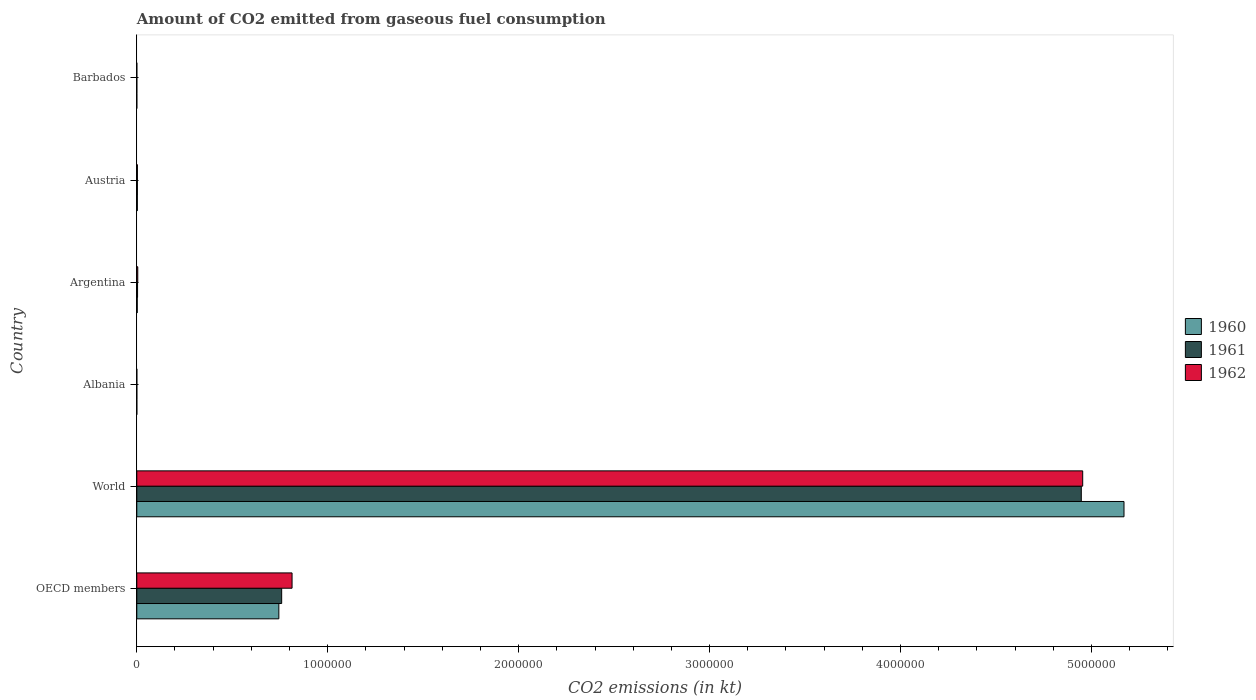How many groups of bars are there?
Your answer should be very brief. 6. Are the number of bars per tick equal to the number of legend labels?
Make the answer very short. Yes. Are the number of bars on each tick of the Y-axis equal?
Provide a short and direct response. Yes. How many bars are there on the 4th tick from the top?
Make the answer very short. 3. How many bars are there on the 3rd tick from the bottom?
Your answer should be compact. 3. What is the label of the 4th group of bars from the top?
Offer a very short reply. Albania. In how many cases, is the number of bars for a given country not equal to the number of legend labels?
Provide a succinct answer. 0. What is the amount of CO2 emitted in 1961 in Austria?
Keep it short and to the point. 3091.28. Across all countries, what is the maximum amount of CO2 emitted in 1961?
Ensure brevity in your answer.  4.95e+06. Across all countries, what is the minimum amount of CO2 emitted in 1961?
Offer a terse response. 7.33. In which country was the amount of CO2 emitted in 1960 minimum?
Keep it short and to the point. Barbados. What is the total amount of CO2 emitted in 1960 in the graph?
Your answer should be compact. 5.92e+06. What is the difference between the amount of CO2 emitted in 1960 in Argentina and that in OECD members?
Your answer should be compact. -7.42e+05. What is the difference between the amount of CO2 emitted in 1962 in Argentina and the amount of CO2 emitted in 1961 in OECD members?
Ensure brevity in your answer.  -7.54e+05. What is the average amount of CO2 emitted in 1960 per country?
Your answer should be very brief. 9.87e+05. What is the difference between the amount of CO2 emitted in 1961 and amount of CO2 emitted in 1962 in Argentina?
Your answer should be very brief. -1078.1. What is the ratio of the amount of CO2 emitted in 1960 in Albania to that in Austria?
Your response must be concise. 0.03. What is the difference between the highest and the second highest amount of CO2 emitted in 1962?
Your answer should be compact. 4.14e+06. What is the difference between the highest and the lowest amount of CO2 emitted in 1960?
Offer a very short reply. 5.17e+06. In how many countries, is the amount of CO2 emitted in 1960 greater than the average amount of CO2 emitted in 1960 taken over all countries?
Give a very brief answer. 1. Is the sum of the amount of CO2 emitted in 1960 in Austria and World greater than the maximum amount of CO2 emitted in 1961 across all countries?
Your response must be concise. Yes. What does the 1st bar from the top in Barbados represents?
Offer a very short reply. 1962. How many bars are there?
Make the answer very short. 18. How many countries are there in the graph?
Offer a very short reply. 6. Are the values on the major ticks of X-axis written in scientific E-notation?
Provide a succinct answer. No. Does the graph contain grids?
Offer a very short reply. No. How many legend labels are there?
Provide a succinct answer. 3. How are the legend labels stacked?
Your response must be concise. Vertical. What is the title of the graph?
Ensure brevity in your answer.  Amount of CO2 emitted from gaseous fuel consumption. Does "1982" appear as one of the legend labels in the graph?
Your answer should be compact. No. What is the label or title of the X-axis?
Your answer should be compact. CO2 emissions (in kt). What is the CO2 emissions (in kt) in 1960 in OECD members?
Your answer should be compact. 7.44e+05. What is the CO2 emissions (in kt) in 1961 in OECD members?
Offer a terse response. 7.59e+05. What is the CO2 emissions (in kt) in 1962 in OECD members?
Your answer should be compact. 8.13e+05. What is the CO2 emissions (in kt) of 1960 in World?
Keep it short and to the point. 5.17e+06. What is the CO2 emissions (in kt) of 1961 in World?
Provide a succinct answer. 4.95e+06. What is the CO2 emissions (in kt) in 1962 in World?
Make the answer very short. 4.95e+06. What is the CO2 emissions (in kt) in 1960 in Albania?
Provide a short and direct response. 84.34. What is the CO2 emissions (in kt) in 1961 in Albania?
Your response must be concise. 84.34. What is the CO2 emissions (in kt) in 1962 in Albania?
Keep it short and to the point. 84.34. What is the CO2 emissions (in kt) in 1960 in Argentina?
Offer a terse response. 2365.22. What is the CO2 emissions (in kt) in 1961 in Argentina?
Offer a very short reply. 4033.7. What is the CO2 emissions (in kt) in 1962 in Argentina?
Provide a short and direct response. 5111.8. What is the CO2 emissions (in kt) of 1960 in Austria?
Give a very brief answer. 2922.6. What is the CO2 emissions (in kt) of 1961 in Austria?
Give a very brief answer. 3091.28. What is the CO2 emissions (in kt) of 1962 in Austria?
Ensure brevity in your answer.  3241.63. What is the CO2 emissions (in kt) of 1960 in Barbados?
Your answer should be compact. 3.67. What is the CO2 emissions (in kt) of 1961 in Barbados?
Your answer should be compact. 7.33. What is the CO2 emissions (in kt) in 1962 in Barbados?
Give a very brief answer. 7.33. Across all countries, what is the maximum CO2 emissions (in kt) in 1960?
Provide a short and direct response. 5.17e+06. Across all countries, what is the maximum CO2 emissions (in kt) of 1961?
Your answer should be very brief. 4.95e+06. Across all countries, what is the maximum CO2 emissions (in kt) in 1962?
Your response must be concise. 4.95e+06. Across all countries, what is the minimum CO2 emissions (in kt) in 1960?
Give a very brief answer. 3.67. Across all countries, what is the minimum CO2 emissions (in kt) in 1961?
Your answer should be very brief. 7.33. Across all countries, what is the minimum CO2 emissions (in kt) in 1962?
Offer a very short reply. 7.33. What is the total CO2 emissions (in kt) in 1960 in the graph?
Provide a succinct answer. 5.92e+06. What is the total CO2 emissions (in kt) in 1961 in the graph?
Keep it short and to the point. 5.71e+06. What is the total CO2 emissions (in kt) in 1962 in the graph?
Your answer should be compact. 5.78e+06. What is the difference between the CO2 emissions (in kt) in 1960 in OECD members and that in World?
Give a very brief answer. -4.43e+06. What is the difference between the CO2 emissions (in kt) of 1961 in OECD members and that in World?
Make the answer very short. -4.19e+06. What is the difference between the CO2 emissions (in kt) of 1962 in OECD members and that in World?
Offer a very short reply. -4.14e+06. What is the difference between the CO2 emissions (in kt) of 1960 in OECD members and that in Albania?
Offer a very short reply. 7.44e+05. What is the difference between the CO2 emissions (in kt) of 1961 in OECD members and that in Albania?
Provide a succinct answer. 7.59e+05. What is the difference between the CO2 emissions (in kt) in 1962 in OECD members and that in Albania?
Offer a very short reply. 8.13e+05. What is the difference between the CO2 emissions (in kt) in 1960 in OECD members and that in Argentina?
Provide a succinct answer. 7.42e+05. What is the difference between the CO2 emissions (in kt) of 1961 in OECD members and that in Argentina?
Your answer should be compact. 7.55e+05. What is the difference between the CO2 emissions (in kt) in 1962 in OECD members and that in Argentina?
Provide a short and direct response. 8.08e+05. What is the difference between the CO2 emissions (in kt) of 1960 in OECD members and that in Austria?
Ensure brevity in your answer.  7.41e+05. What is the difference between the CO2 emissions (in kt) of 1961 in OECD members and that in Austria?
Offer a very short reply. 7.56e+05. What is the difference between the CO2 emissions (in kt) of 1962 in OECD members and that in Austria?
Make the answer very short. 8.10e+05. What is the difference between the CO2 emissions (in kt) in 1960 in OECD members and that in Barbados?
Provide a short and direct response. 7.44e+05. What is the difference between the CO2 emissions (in kt) of 1961 in OECD members and that in Barbados?
Provide a succinct answer. 7.59e+05. What is the difference between the CO2 emissions (in kt) in 1962 in OECD members and that in Barbados?
Offer a terse response. 8.13e+05. What is the difference between the CO2 emissions (in kt) in 1960 in World and that in Albania?
Ensure brevity in your answer.  5.17e+06. What is the difference between the CO2 emissions (in kt) in 1961 in World and that in Albania?
Your answer should be compact. 4.95e+06. What is the difference between the CO2 emissions (in kt) in 1962 in World and that in Albania?
Provide a short and direct response. 4.95e+06. What is the difference between the CO2 emissions (in kt) of 1960 in World and that in Argentina?
Your answer should be compact. 5.17e+06. What is the difference between the CO2 emissions (in kt) in 1961 in World and that in Argentina?
Provide a succinct answer. 4.94e+06. What is the difference between the CO2 emissions (in kt) of 1962 in World and that in Argentina?
Provide a succinct answer. 4.95e+06. What is the difference between the CO2 emissions (in kt) of 1960 in World and that in Austria?
Offer a very short reply. 5.17e+06. What is the difference between the CO2 emissions (in kt) of 1961 in World and that in Austria?
Make the answer very short. 4.94e+06. What is the difference between the CO2 emissions (in kt) in 1962 in World and that in Austria?
Ensure brevity in your answer.  4.95e+06. What is the difference between the CO2 emissions (in kt) in 1960 in World and that in Barbados?
Provide a succinct answer. 5.17e+06. What is the difference between the CO2 emissions (in kt) in 1961 in World and that in Barbados?
Provide a succinct answer. 4.95e+06. What is the difference between the CO2 emissions (in kt) of 1962 in World and that in Barbados?
Make the answer very short. 4.95e+06. What is the difference between the CO2 emissions (in kt) in 1960 in Albania and that in Argentina?
Provide a succinct answer. -2280.87. What is the difference between the CO2 emissions (in kt) in 1961 in Albania and that in Argentina?
Your answer should be very brief. -3949.36. What is the difference between the CO2 emissions (in kt) of 1962 in Albania and that in Argentina?
Provide a succinct answer. -5027.46. What is the difference between the CO2 emissions (in kt) in 1960 in Albania and that in Austria?
Your response must be concise. -2838.26. What is the difference between the CO2 emissions (in kt) in 1961 in Albania and that in Austria?
Keep it short and to the point. -3006.94. What is the difference between the CO2 emissions (in kt) of 1962 in Albania and that in Austria?
Offer a terse response. -3157.29. What is the difference between the CO2 emissions (in kt) of 1960 in Albania and that in Barbados?
Your answer should be compact. 80.67. What is the difference between the CO2 emissions (in kt) of 1961 in Albania and that in Barbados?
Your answer should be very brief. 77.01. What is the difference between the CO2 emissions (in kt) in 1962 in Albania and that in Barbados?
Offer a terse response. 77.01. What is the difference between the CO2 emissions (in kt) in 1960 in Argentina and that in Austria?
Ensure brevity in your answer.  -557.38. What is the difference between the CO2 emissions (in kt) of 1961 in Argentina and that in Austria?
Your response must be concise. 942.42. What is the difference between the CO2 emissions (in kt) of 1962 in Argentina and that in Austria?
Give a very brief answer. 1870.17. What is the difference between the CO2 emissions (in kt) of 1960 in Argentina and that in Barbados?
Your answer should be very brief. 2361.55. What is the difference between the CO2 emissions (in kt) of 1961 in Argentina and that in Barbados?
Provide a succinct answer. 4026.37. What is the difference between the CO2 emissions (in kt) of 1962 in Argentina and that in Barbados?
Your response must be concise. 5104.46. What is the difference between the CO2 emissions (in kt) in 1960 in Austria and that in Barbados?
Provide a succinct answer. 2918.93. What is the difference between the CO2 emissions (in kt) in 1961 in Austria and that in Barbados?
Your answer should be very brief. 3083.95. What is the difference between the CO2 emissions (in kt) of 1962 in Austria and that in Barbados?
Make the answer very short. 3234.29. What is the difference between the CO2 emissions (in kt) of 1960 in OECD members and the CO2 emissions (in kt) of 1961 in World?
Provide a succinct answer. -4.20e+06. What is the difference between the CO2 emissions (in kt) in 1960 in OECD members and the CO2 emissions (in kt) in 1962 in World?
Keep it short and to the point. -4.21e+06. What is the difference between the CO2 emissions (in kt) in 1961 in OECD members and the CO2 emissions (in kt) in 1962 in World?
Offer a terse response. -4.20e+06. What is the difference between the CO2 emissions (in kt) in 1960 in OECD members and the CO2 emissions (in kt) in 1961 in Albania?
Your answer should be very brief. 7.44e+05. What is the difference between the CO2 emissions (in kt) in 1960 in OECD members and the CO2 emissions (in kt) in 1962 in Albania?
Your answer should be very brief. 7.44e+05. What is the difference between the CO2 emissions (in kt) of 1961 in OECD members and the CO2 emissions (in kt) of 1962 in Albania?
Offer a very short reply. 7.59e+05. What is the difference between the CO2 emissions (in kt) in 1960 in OECD members and the CO2 emissions (in kt) in 1961 in Argentina?
Ensure brevity in your answer.  7.40e+05. What is the difference between the CO2 emissions (in kt) in 1960 in OECD members and the CO2 emissions (in kt) in 1962 in Argentina?
Ensure brevity in your answer.  7.39e+05. What is the difference between the CO2 emissions (in kt) of 1961 in OECD members and the CO2 emissions (in kt) of 1962 in Argentina?
Make the answer very short. 7.54e+05. What is the difference between the CO2 emissions (in kt) in 1960 in OECD members and the CO2 emissions (in kt) in 1961 in Austria?
Ensure brevity in your answer.  7.41e+05. What is the difference between the CO2 emissions (in kt) in 1960 in OECD members and the CO2 emissions (in kt) in 1962 in Austria?
Make the answer very short. 7.41e+05. What is the difference between the CO2 emissions (in kt) of 1961 in OECD members and the CO2 emissions (in kt) of 1962 in Austria?
Your answer should be very brief. 7.56e+05. What is the difference between the CO2 emissions (in kt) in 1960 in OECD members and the CO2 emissions (in kt) in 1961 in Barbados?
Give a very brief answer. 7.44e+05. What is the difference between the CO2 emissions (in kt) in 1960 in OECD members and the CO2 emissions (in kt) in 1962 in Barbados?
Keep it short and to the point. 7.44e+05. What is the difference between the CO2 emissions (in kt) in 1961 in OECD members and the CO2 emissions (in kt) in 1962 in Barbados?
Give a very brief answer. 7.59e+05. What is the difference between the CO2 emissions (in kt) of 1960 in World and the CO2 emissions (in kt) of 1961 in Albania?
Offer a very short reply. 5.17e+06. What is the difference between the CO2 emissions (in kt) in 1960 in World and the CO2 emissions (in kt) in 1962 in Albania?
Give a very brief answer. 5.17e+06. What is the difference between the CO2 emissions (in kt) in 1961 in World and the CO2 emissions (in kt) in 1962 in Albania?
Ensure brevity in your answer.  4.95e+06. What is the difference between the CO2 emissions (in kt) of 1960 in World and the CO2 emissions (in kt) of 1961 in Argentina?
Your answer should be compact. 5.17e+06. What is the difference between the CO2 emissions (in kt) of 1960 in World and the CO2 emissions (in kt) of 1962 in Argentina?
Your answer should be compact. 5.17e+06. What is the difference between the CO2 emissions (in kt) in 1961 in World and the CO2 emissions (in kt) in 1962 in Argentina?
Your answer should be compact. 4.94e+06. What is the difference between the CO2 emissions (in kt) in 1960 in World and the CO2 emissions (in kt) in 1961 in Austria?
Offer a very short reply. 5.17e+06. What is the difference between the CO2 emissions (in kt) of 1960 in World and the CO2 emissions (in kt) of 1962 in Austria?
Make the answer very short. 5.17e+06. What is the difference between the CO2 emissions (in kt) of 1961 in World and the CO2 emissions (in kt) of 1962 in Austria?
Make the answer very short. 4.94e+06. What is the difference between the CO2 emissions (in kt) of 1960 in World and the CO2 emissions (in kt) of 1961 in Barbados?
Offer a very short reply. 5.17e+06. What is the difference between the CO2 emissions (in kt) of 1960 in World and the CO2 emissions (in kt) of 1962 in Barbados?
Provide a succinct answer. 5.17e+06. What is the difference between the CO2 emissions (in kt) in 1961 in World and the CO2 emissions (in kt) in 1962 in Barbados?
Ensure brevity in your answer.  4.95e+06. What is the difference between the CO2 emissions (in kt) of 1960 in Albania and the CO2 emissions (in kt) of 1961 in Argentina?
Make the answer very short. -3949.36. What is the difference between the CO2 emissions (in kt) of 1960 in Albania and the CO2 emissions (in kt) of 1962 in Argentina?
Give a very brief answer. -5027.46. What is the difference between the CO2 emissions (in kt) in 1961 in Albania and the CO2 emissions (in kt) in 1962 in Argentina?
Keep it short and to the point. -5027.46. What is the difference between the CO2 emissions (in kt) in 1960 in Albania and the CO2 emissions (in kt) in 1961 in Austria?
Your answer should be compact. -3006.94. What is the difference between the CO2 emissions (in kt) of 1960 in Albania and the CO2 emissions (in kt) of 1962 in Austria?
Offer a terse response. -3157.29. What is the difference between the CO2 emissions (in kt) in 1961 in Albania and the CO2 emissions (in kt) in 1962 in Austria?
Your answer should be compact. -3157.29. What is the difference between the CO2 emissions (in kt) of 1960 in Albania and the CO2 emissions (in kt) of 1961 in Barbados?
Your answer should be compact. 77.01. What is the difference between the CO2 emissions (in kt) in 1960 in Albania and the CO2 emissions (in kt) in 1962 in Barbados?
Your response must be concise. 77.01. What is the difference between the CO2 emissions (in kt) in 1961 in Albania and the CO2 emissions (in kt) in 1962 in Barbados?
Keep it short and to the point. 77.01. What is the difference between the CO2 emissions (in kt) in 1960 in Argentina and the CO2 emissions (in kt) in 1961 in Austria?
Your answer should be compact. -726.07. What is the difference between the CO2 emissions (in kt) in 1960 in Argentina and the CO2 emissions (in kt) in 1962 in Austria?
Ensure brevity in your answer.  -876.41. What is the difference between the CO2 emissions (in kt) of 1961 in Argentina and the CO2 emissions (in kt) of 1962 in Austria?
Keep it short and to the point. 792.07. What is the difference between the CO2 emissions (in kt) in 1960 in Argentina and the CO2 emissions (in kt) in 1961 in Barbados?
Provide a succinct answer. 2357.88. What is the difference between the CO2 emissions (in kt) of 1960 in Argentina and the CO2 emissions (in kt) of 1962 in Barbados?
Make the answer very short. 2357.88. What is the difference between the CO2 emissions (in kt) of 1961 in Argentina and the CO2 emissions (in kt) of 1962 in Barbados?
Your response must be concise. 4026.37. What is the difference between the CO2 emissions (in kt) in 1960 in Austria and the CO2 emissions (in kt) in 1961 in Barbados?
Provide a succinct answer. 2915.26. What is the difference between the CO2 emissions (in kt) of 1960 in Austria and the CO2 emissions (in kt) of 1962 in Barbados?
Your response must be concise. 2915.26. What is the difference between the CO2 emissions (in kt) in 1961 in Austria and the CO2 emissions (in kt) in 1962 in Barbados?
Your answer should be very brief. 3083.95. What is the average CO2 emissions (in kt) of 1960 per country?
Provide a succinct answer. 9.87e+05. What is the average CO2 emissions (in kt) in 1961 per country?
Make the answer very short. 9.52e+05. What is the average CO2 emissions (in kt) of 1962 per country?
Make the answer very short. 9.63e+05. What is the difference between the CO2 emissions (in kt) of 1960 and CO2 emissions (in kt) of 1961 in OECD members?
Provide a short and direct response. -1.48e+04. What is the difference between the CO2 emissions (in kt) in 1960 and CO2 emissions (in kt) in 1962 in OECD members?
Your response must be concise. -6.92e+04. What is the difference between the CO2 emissions (in kt) of 1961 and CO2 emissions (in kt) of 1962 in OECD members?
Make the answer very short. -5.44e+04. What is the difference between the CO2 emissions (in kt) in 1960 and CO2 emissions (in kt) in 1961 in World?
Provide a succinct answer. 2.24e+05. What is the difference between the CO2 emissions (in kt) in 1960 and CO2 emissions (in kt) in 1962 in World?
Provide a short and direct response. 2.16e+05. What is the difference between the CO2 emissions (in kt) of 1961 and CO2 emissions (in kt) of 1962 in World?
Keep it short and to the point. -7334. What is the difference between the CO2 emissions (in kt) in 1961 and CO2 emissions (in kt) in 1962 in Albania?
Make the answer very short. 0. What is the difference between the CO2 emissions (in kt) in 1960 and CO2 emissions (in kt) in 1961 in Argentina?
Offer a very short reply. -1668.48. What is the difference between the CO2 emissions (in kt) in 1960 and CO2 emissions (in kt) in 1962 in Argentina?
Your answer should be very brief. -2746.58. What is the difference between the CO2 emissions (in kt) of 1961 and CO2 emissions (in kt) of 1962 in Argentina?
Offer a terse response. -1078.1. What is the difference between the CO2 emissions (in kt) in 1960 and CO2 emissions (in kt) in 1961 in Austria?
Your answer should be compact. -168.68. What is the difference between the CO2 emissions (in kt) of 1960 and CO2 emissions (in kt) of 1962 in Austria?
Your answer should be very brief. -319.03. What is the difference between the CO2 emissions (in kt) in 1961 and CO2 emissions (in kt) in 1962 in Austria?
Your answer should be very brief. -150.35. What is the difference between the CO2 emissions (in kt) in 1960 and CO2 emissions (in kt) in 1961 in Barbados?
Your answer should be compact. -3.67. What is the difference between the CO2 emissions (in kt) of 1960 and CO2 emissions (in kt) of 1962 in Barbados?
Provide a short and direct response. -3.67. What is the difference between the CO2 emissions (in kt) of 1961 and CO2 emissions (in kt) of 1962 in Barbados?
Your answer should be compact. 0. What is the ratio of the CO2 emissions (in kt) in 1960 in OECD members to that in World?
Your answer should be compact. 0.14. What is the ratio of the CO2 emissions (in kt) in 1961 in OECD members to that in World?
Provide a succinct answer. 0.15. What is the ratio of the CO2 emissions (in kt) of 1962 in OECD members to that in World?
Your answer should be very brief. 0.16. What is the ratio of the CO2 emissions (in kt) in 1960 in OECD members to that in Albania?
Provide a succinct answer. 8821.78. What is the ratio of the CO2 emissions (in kt) in 1961 in OECD members to that in Albania?
Offer a terse response. 8997.23. What is the ratio of the CO2 emissions (in kt) of 1962 in OECD members to that in Albania?
Provide a short and direct response. 9641.88. What is the ratio of the CO2 emissions (in kt) of 1960 in OECD members to that in Argentina?
Keep it short and to the point. 314.57. What is the ratio of the CO2 emissions (in kt) in 1961 in OECD members to that in Argentina?
Your response must be concise. 188.12. What is the ratio of the CO2 emissions (in kt) of 1962 in OECD members to that in Argentina?
Keep it short and to the point. 159.08. What is the ratio of the CO2 emissions (in kt) in 1960 in OECD members to that in Austria?
Keep it short and to the point. 254.58. What is the ratio of the CO2 emissions (in kt) of 1961 in OECD members to that in Austria?
Your answer should be compact. 245.48. What is the ratio of the CO2 emissions (in kt) in 1962 in OECD members to that in Austria?
Provide a short and direct response. 250.86. What is the ratio of the CO2 emissions (in kt) of 1960 in OECD members to that in Barbados?
Keep it short and to the point. 2.03e+05. What is the ratio of the CO2 emissions (in kt) of 1961 in OECD members to that in Barbados?
Ensure brevity in your answer.  1.03e+05. What is the ratio of the CO2 emissions (in kt) of 1962 in OECD members to that in Barbados?
Your answer should be very brief. 1.11e+05. What is the ratio of the CO2 emissions (in kt) of 1960 in World to that in Albania?
Offer a terse response. 6.13e+04. What is the ratio of the CO2 emissions (in kt) in 1961 in World to that in Albania?
Make the answer very short. 5.87e+04. What is the ratio of the CO2 emissions (in kt) in 1962 in World to that in Albania?
Your answer should be compact. 5.87e+04. What is the ratio of the CO2 emissions (in kt) in 1960 in World to that in Argentina?
Provide a succinct answer. 2186.05. What is the ratio of the CO2 emissions (in kt) in 1961 in World to that in Argentina?
Your answer should be very brief. 1226.36. What is the ratio of the CO2 emissions (in kt) of 1962 in World to that in Argentina?
Ensure brevity in your answer.  969.15. What is the ratio of the CO2 emissions (in kt) of 1960 in World to that in Austria?
Give a very brief answer. 1769.13. What is the ratio of the CO2 emissions (in kt) of 1961 in World to that in Austria?
Your answer should be compact. 1600.24. What is the ratio of the CO2 emissions (in kt) of 1962 in World to that in Austria?
Make the answer very short. 1528.28. What is the ratio of the CO2 emissions (in kt) in 1960 in World to that in Barbados?
Your answer should be compact. 1.41e+06. What is the ratio of the CO2 emissions (in kt) of 1961 in World to that in Barbados?
Provide a short and direct response. 6.74e+05. What is the ratio of the CO2 emissions (in kt) of 1962 in World to that in Barbados?
Offer a very short reply. 6.76e+05. What is the ratio of the CO2 emissions (in kt) of 1960 in Albania to that in Argentina?
Provide a succinct answer. 0.04. What is the ratio of the CO2 emissions (in kt) of 1961 in Albania to that in Argentina?
Provide a succinct answer. 0.02. What is the ratio of the CO2 emissions (in kt) of 1962 in Albania to that in Argentina?
Keep it short and to the point. 0.02. What is the ratio of the CO2 emissions (in kt) of 1960 in Albania to that in Austria?
Your response must be concise. 0.03. What is the ratio of the CO2 emissions (in kt) of 1961 in Albania to that in Austria?
Provide a short and direct response. 0.03. What is the ratio of the CO2 emissions (in kt) of 1962 in Albania to that in Austria?
Offer a terse response. 0.03. What is the ratio of the CO2 emissions (in kt) of 1960 in Albania to that in Barbados?
Your answer should be very brief. 23. What is the ratio of the CO2 emissions (in kt) in 1962 in Albania to that in Barbados?
Give a very brief answer. 11.5. What is the ratio of the CO2 emissions (in kt) in 1960 in Argentina to that in Austria?
Ensure brevity in your answer.  0.81. What is the ratio of the CO2 emissions (in kt) of 1961 in Argentina to that in Austria?
Provide a succinct answer. 1.3. What is the ratio of the CO2 emissions (in kt) in 1962 in Argentina to that in Austria?
Provide a succinct answer. 1.58. What is the ratio of the CO2 emissions (in kt) in 1960 in Argentina to that in Barbados?
Make the answer very short. 645. What is the ratio of the CO2 emissions (in kt) of 1961 in Argentina to that in Barbados?
Offer a terse response. 550. What is the ratio of the CO2 emissions (in kt) of 1962 in Argentina to that in Barbados?
Provide a succinct answer. 697. What is the ratio of the CO2 emissions (in kt) in 1960 in Austria to that in Barbados?
Ensure brevity in your answer.  797. What is the ratio of the CO2 emissions (in kt) in 1961 in Austria to that in Barbados?
Your response must be concise. 421.5. What is the ratio of the CO2 emissions (in kt) in 1962 in Austria to that in Barbados?
Offer a very short reply. 442. What is the difference between the highest and the second highest CO2 emissions (in kt) of 1960?
Ensure brevity in your answer.  4.43e+06. What is the difference between the highest and the second highest CO2 emissions (in kt) in 1961?
Your answer should be very brief. 4.19e+06. What is the difference between the highest and the second highest CO2 emissions (in kt) of 1962?
Keep it short and to the point. 4.14e+06. What is the difference between the highest and the lowest CO2 emissions (in kt) in 1960?
Keep it short and to the point. 5.17e+06. What is the difference between the highest and the lowest CO2 emissions (in kt) of 1961?
Offer a very short reply. 4.95e+06. What is the difference between the highest and the lowest CO2 emissions (in kt) in 1962?
Make the answer very short. 4.95e+06. 